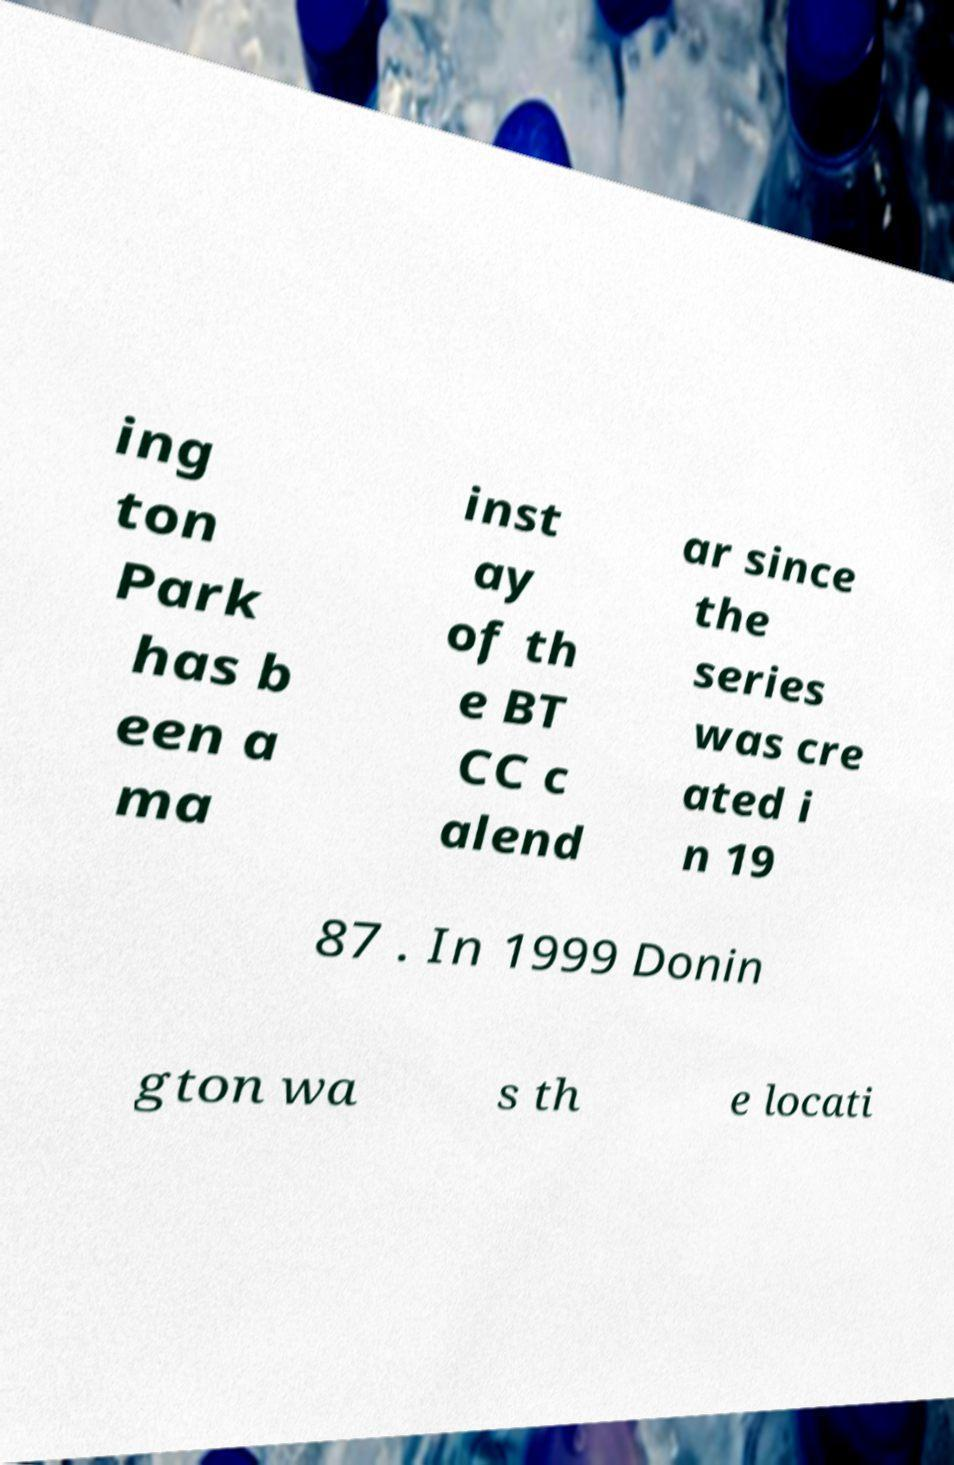Can you accurately transcribe the text from the provided image for me? ing ton Park has b een a ma inst ay of th e BT CC c alend ar since the series was cre ated i n 19 87 . In 1999 Donin gton wa s th e locati 